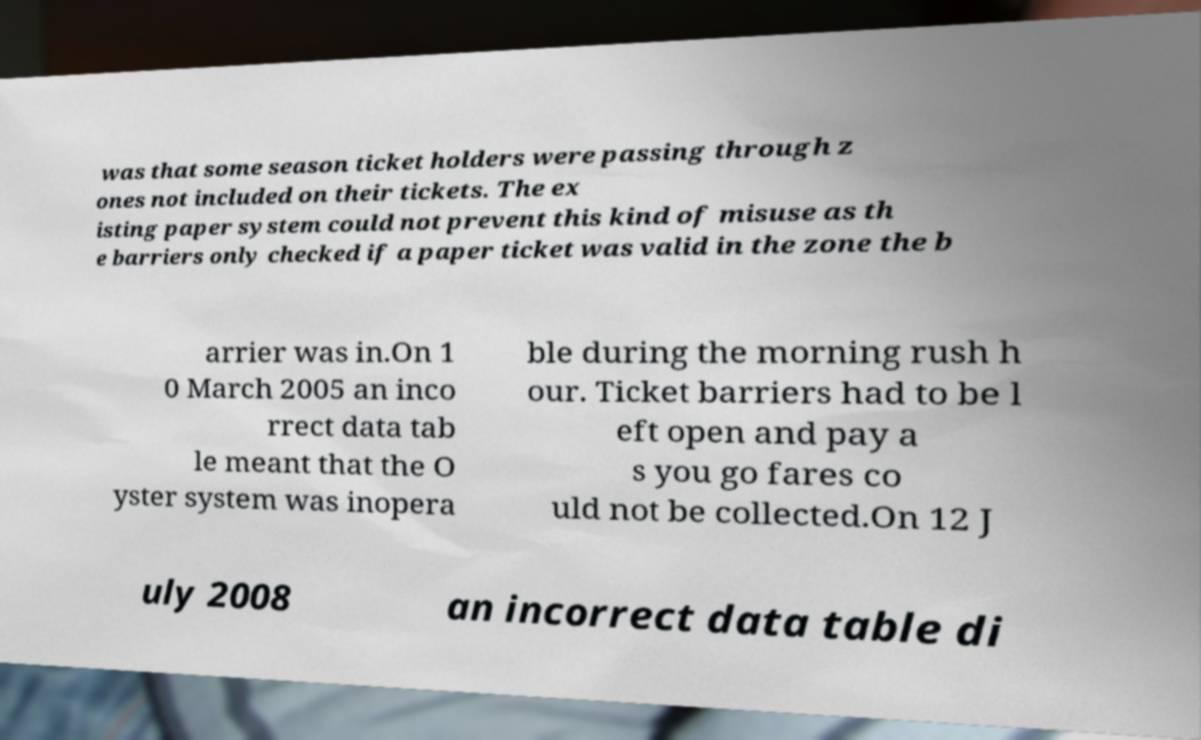Please identify and transcribe the text found in this image. was that some season ticket holders were passing through z ones not included on their tickets. The ex isting paper system could not prevent this kind of misuse as th e barriers only checked if a paper ticket was valid in the zone the b arrier was in.On 1 0 March 2005 an inco rrect data tab le meant that the O yster system was inopera ble during the morning rush h our. Ticket barriers had to be l eft open and pay a s you go fares co uld not be collected.On 12 J uly 2008 an incorrect data table di 